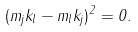Convert formula to latex. <formula><loc_0><loc_0><loc_500><loc_500>( m _ { j } k _ { l } - m _ { l } k _ { j } ) ^ { 2 } = 0 .</formula> 